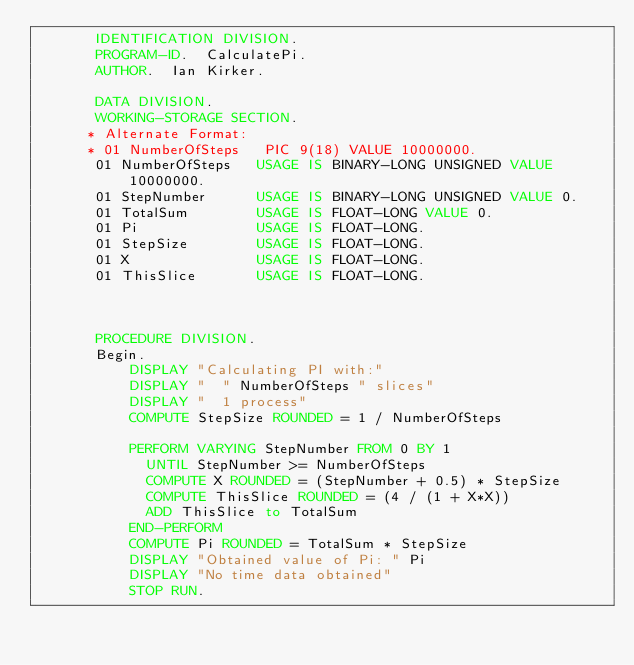Convert code to text. <code><loc_0><loc_0><loc_500><loc_500><_COBOL_>       IDENTIFICATION DIVISION.
       PROGRAM-ID.  CalculatePi.
       AUTHOR.  Ian Kirker.

       DATA DIVISION.
       WORKING-STORAGE SECTION.
      * Alternate Format:
      * 01 NumberOfSteps   PIC 9(18) VALUE 10000000.
       01 NumberOfSteps   USAGE IS BINARY-LONG UNSIGNED VALUE 10000000.
       01 StepNumber      USAGE IS BINARY-LONG UNSIGNED VALUE 0.
       01 TotalSum        USAGE IS FLOAT-LONG VALUE 0.
       01 Pi              USAGE IS FLOAT-LONG.
       01 StepSize        USAGE IS FLOAT-LONG.
       01 X               USAGE IS FLOAT-LONG.
       01 ThisSlice       USAGE IS FLOAT-LONG.



       PROCEDURE DIVISION.
       Begin.
           DISPLAY "Calculating PI with:"
           DISPLAY "  " NumberOfSteps " slices"
           DISPLAY "  1 process"
           COMPUTE StepSize ROUNDED = 1 / NumberOfSteps
           
           PERFORM VARYING StepNumber FROM 0 BY 1 
             UNTIL StepNumber >= NumberOfSteps 
             COMPUTE X ROUNDED = (StepNumber + 0.5) * StepSize
             COMPUTE ThisSlice ROUNDED = (4 / (1 + X*X))
             ADD ThisSlice to TotalSum
           END-PERFORM
           COMPUTE Pi ROUNDED = TotalSum * StepSize
           DISPLAY "Obtained value of Pi: " Pi
           DISPLAY "No time data obtained"
           STOP RUN.

</code> 